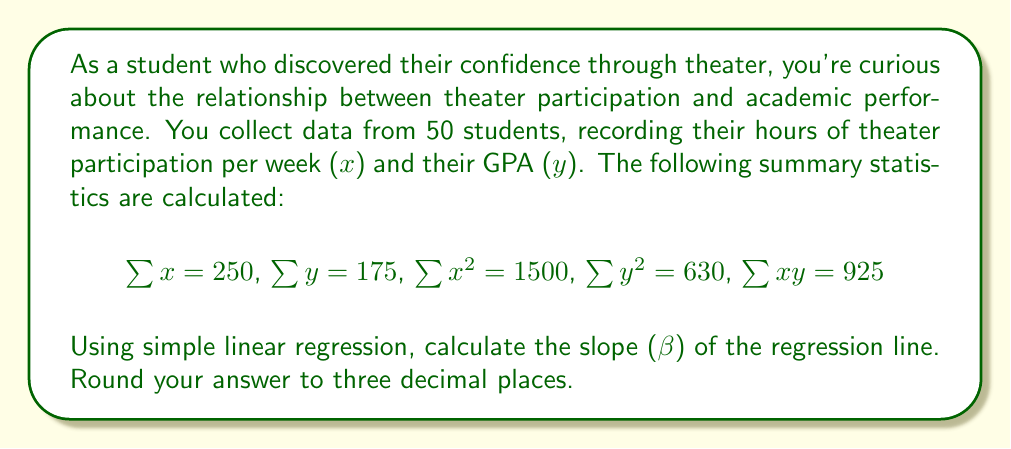Help me with this question. To find the slope (β) of the regression line, we'll use the formula:

$$\beta = \frac{n\sum xy - \sum x \sum y}{n\sum x^2 - (\sum x)^2}$$

Where n is the number of data points (50 in this case).

Let's substitute the given values:

$$\beta = \frac{50(925) - (250)(175)}{50(1500) - (250)^2}$$

Now, let's calculate step by step:

1. Multiply in the numerator:
   $$50(925) = 46250$$
   $$(250)(175) = 43750$$

2. Subtract in the numerator:
   $$46250 - 43750 = 2500$$

3. Multiply in the denominator:
   $$50(1500) = 75000$$
   $$(250)^2 = 62500$$

4. Subtract in the denominator:
   $$75000 - 62500 = 12500$$

5. Divide the numerator by the denominator:
   $$\beta = \frac{2500}{12500} = 0.2$$

Therefore, the slope of the regression line is 0.200 (rounded to three decimal places).
Answer: 0.200 